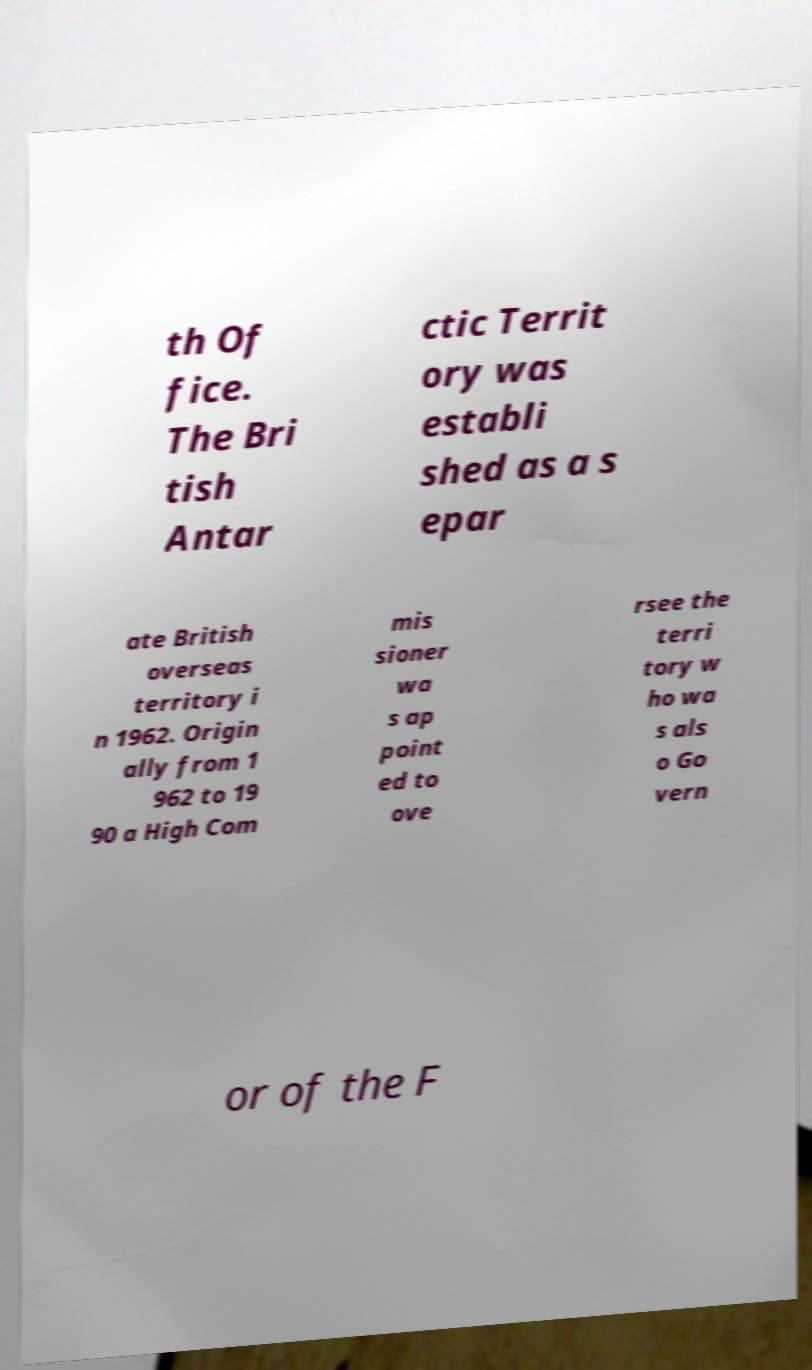Could you extract and type out the text from this image? th Of fice. The Bri tish Antar ctic Territ ory was establi shed as a s epar ate British overseas territory i n 1962. Origin ally from 1 962 to 19 90 a High Com mis sioner wa s ap point ed to ove rsee the terri tory w ho wa s als o Go vern or of the F 